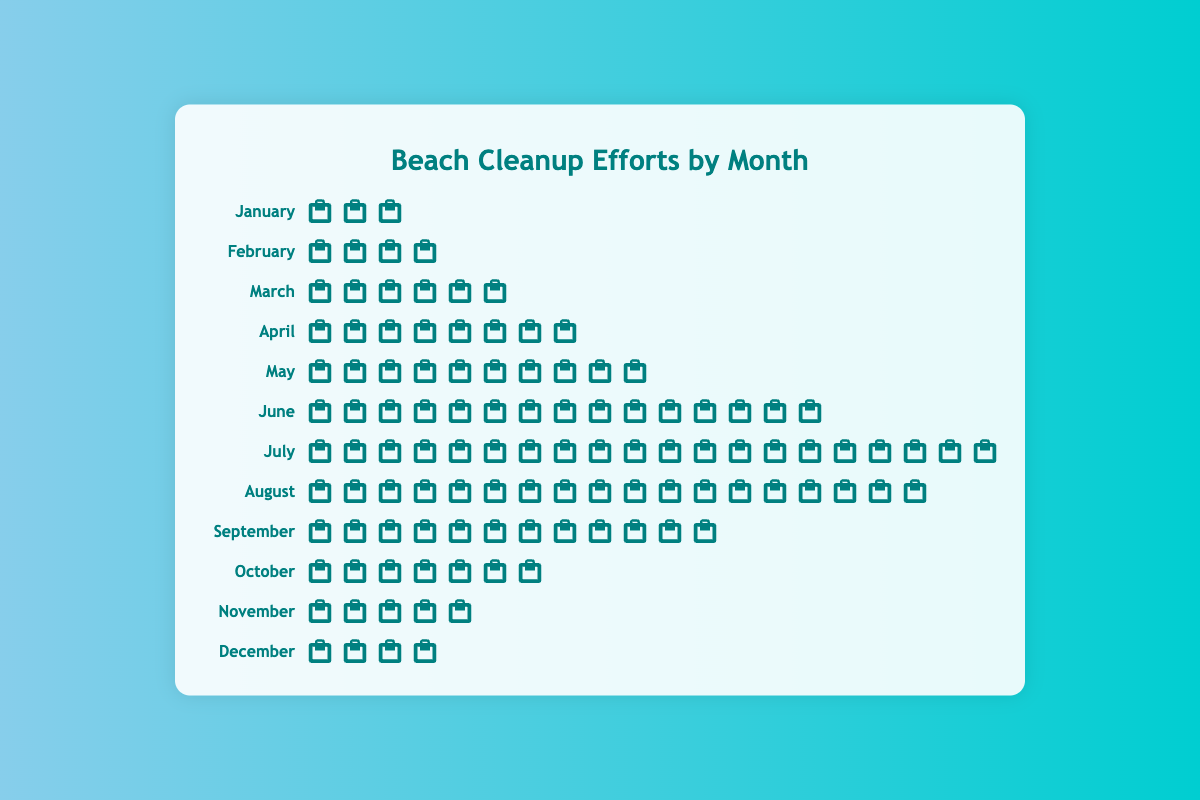Which month had the highest beach cleanup efforts shown by the trash bags? The figure shows each month with the corresponding number of trash bag icons. The month with the most trash bag icons is July.
Answer: July How many trash bags were collected in June and July combined? To find the total number of trash bags collected in June and July, count the trash bag icons for each month and sum them: June has 15 bags and July has 20 bags. So, 15 + 20 = 35.
Answer: 35 Which months had the same number of trash bags collected? By analyzing the trash bag icons, both February and December had 4 trash bags each.
Answer: February and December What is the average number of trash bags collected per month? Add the trash bags for all months and divide by 12. The total is 3+4+6+8+10+15+20+18+12+7+5+4 = 112. Divide by 12 to get 112/12 = 9.33.
Answer: 9.33 Which month saw a decrease in the number of trash bags compared to the previous month? Examine the number of trash bags each month and compare to the previous month. From July to August, the count decreases from 20 bags to 18 bags.
Answer: August In which month was the beach cleanup effort exactly 5 trash bags? Look for the month with 5 trash bag icons. November displays exactly 5 trash bags.
Answer: November How does the number of trash bags in April compare to that in March? Comparing the icons, April has 8 trash bags whereas March has 6. April collected more trash bags than March.
Answer: April has more What is the total number of trash bags collected from January through June? Sum the trash bags for months January through June. This is 3 + 4 + 6 + 8 + 10 + 15 = 46.
Answer: 46 Which month had the lowest beach cleanup effort shown by the trash bags? The month with the fewest number of trash bag icons is January, with 3 trash bags.
Answer: January Is the number of trash bags in May greater than that in October? May has 10 trash bag icons and October has 7. Thus, the number of trash bags in May is greater.
Answer: Yes 